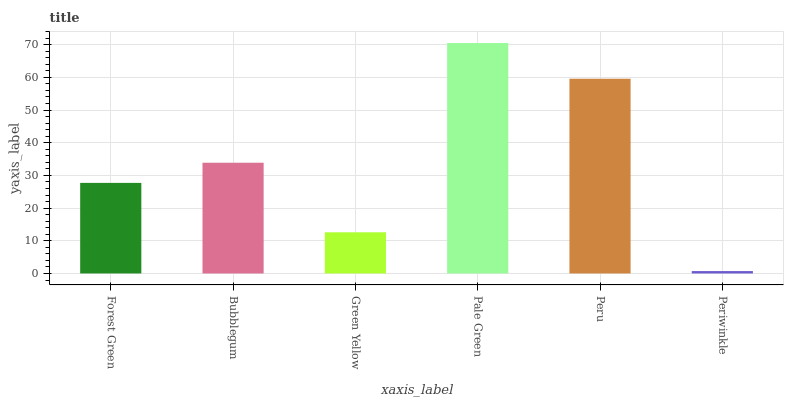Is Periwinkle the minimum?
Answer yes or no. Yes. Is Pale Green the maximum?
Answer yes or no. Yes. Is Bubblegum the minimum?
Answer yes or no. No. Is Bubblegum the maximum?
Answer yes or no. No. Is Bubblegum greater than Forest Green?
Answer yes or no. Yes. Is Forest Green less than Bubblegum?
Answer yes or no. Yes. Is Forest Green greater than Bubblegum?
Answer yes or no. No. Is Bubblegum less than Forest Green?
Answer yes or no. No. Is Bubblegum the high median?
Answer yes or no. Yes. Is Forest Green the low median?
Answer yes or no. Yes. Is Periwinkle the high median?
Answer yes or no. No. Is Pale Green the low median?
Answer yes or no. No. 